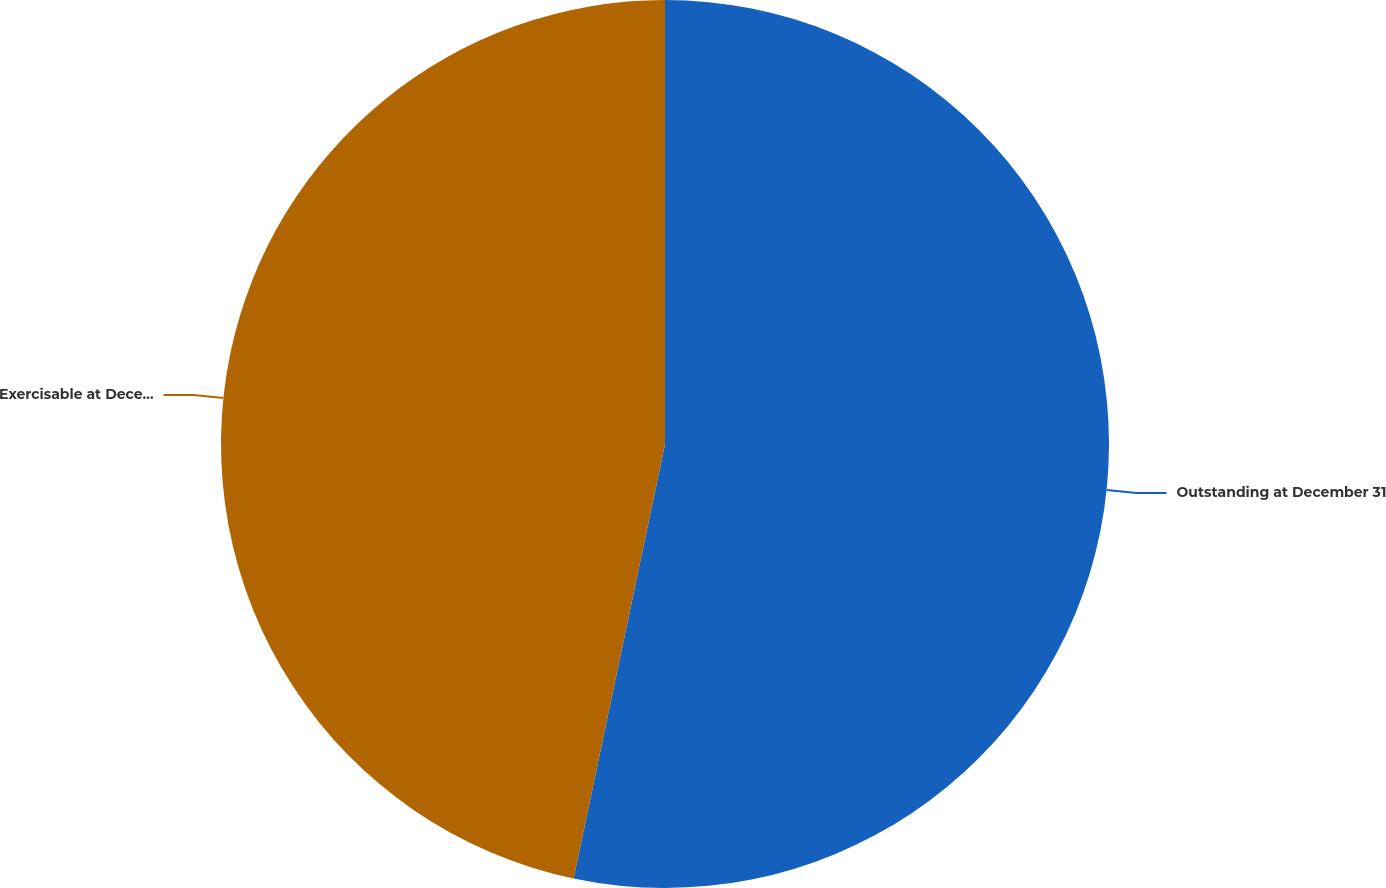Convert chart. <chart><loc_0><loc_0><loc_500><loc_500><pie_chart><fcel>Outstanding at December 31<fcel>Exercisable at December 31<nl><fcel>53.3%<fcel>46.7%<nl></chart> 